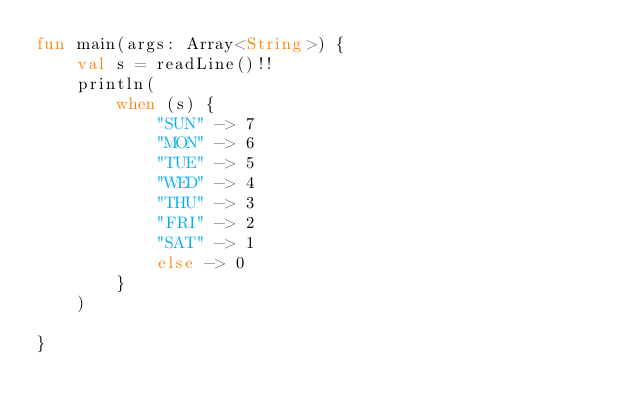<code> <loc_0><loc_0><loc_500><loc_500><_Kotlin_>fun main(args: Array<String>) {
    val s = readLine()!!
    println(
        when (s) {
            "SUN" -> 7
            "MON" -> 6
            "TUE" -> 5
            "WED" -> 4
            "THU" -> 3
            "FRI" -> 2
            "SAT" -> 1
            else -> 0
        }
    )

}</code> 